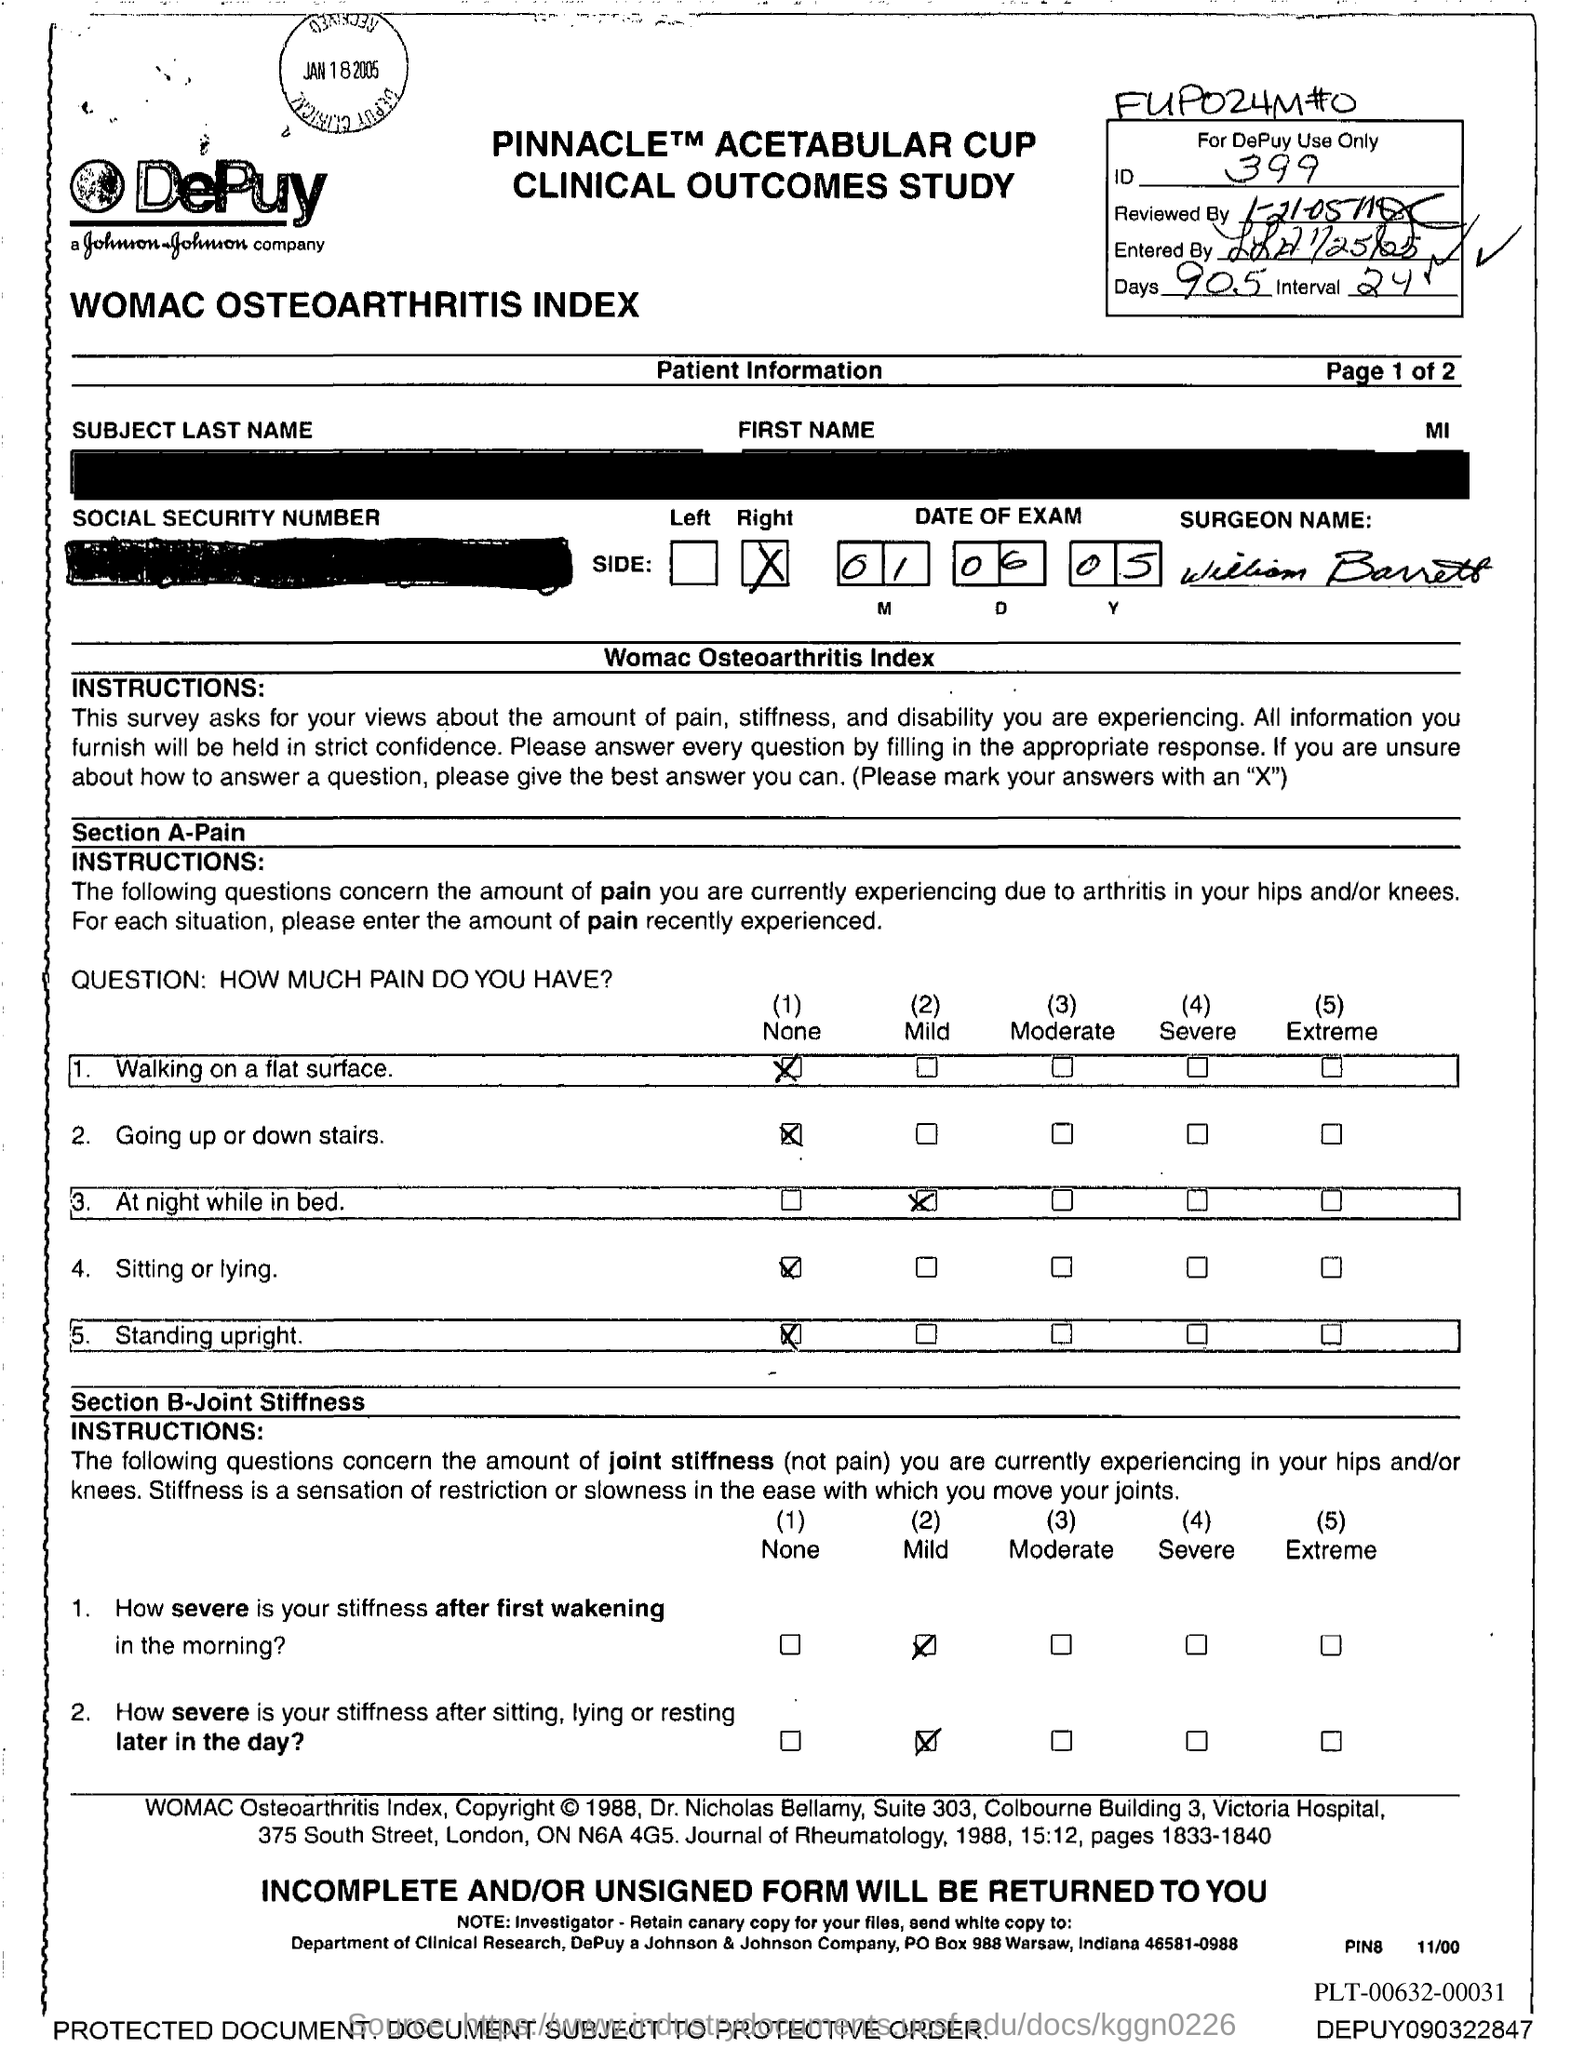Give some essential details in this illustration. The date of the exam mentioned in the document is June 1, 2005. Nine hundred and five days are mentioned in the document. What is the identification number mentioned in the document? It is 399.. 